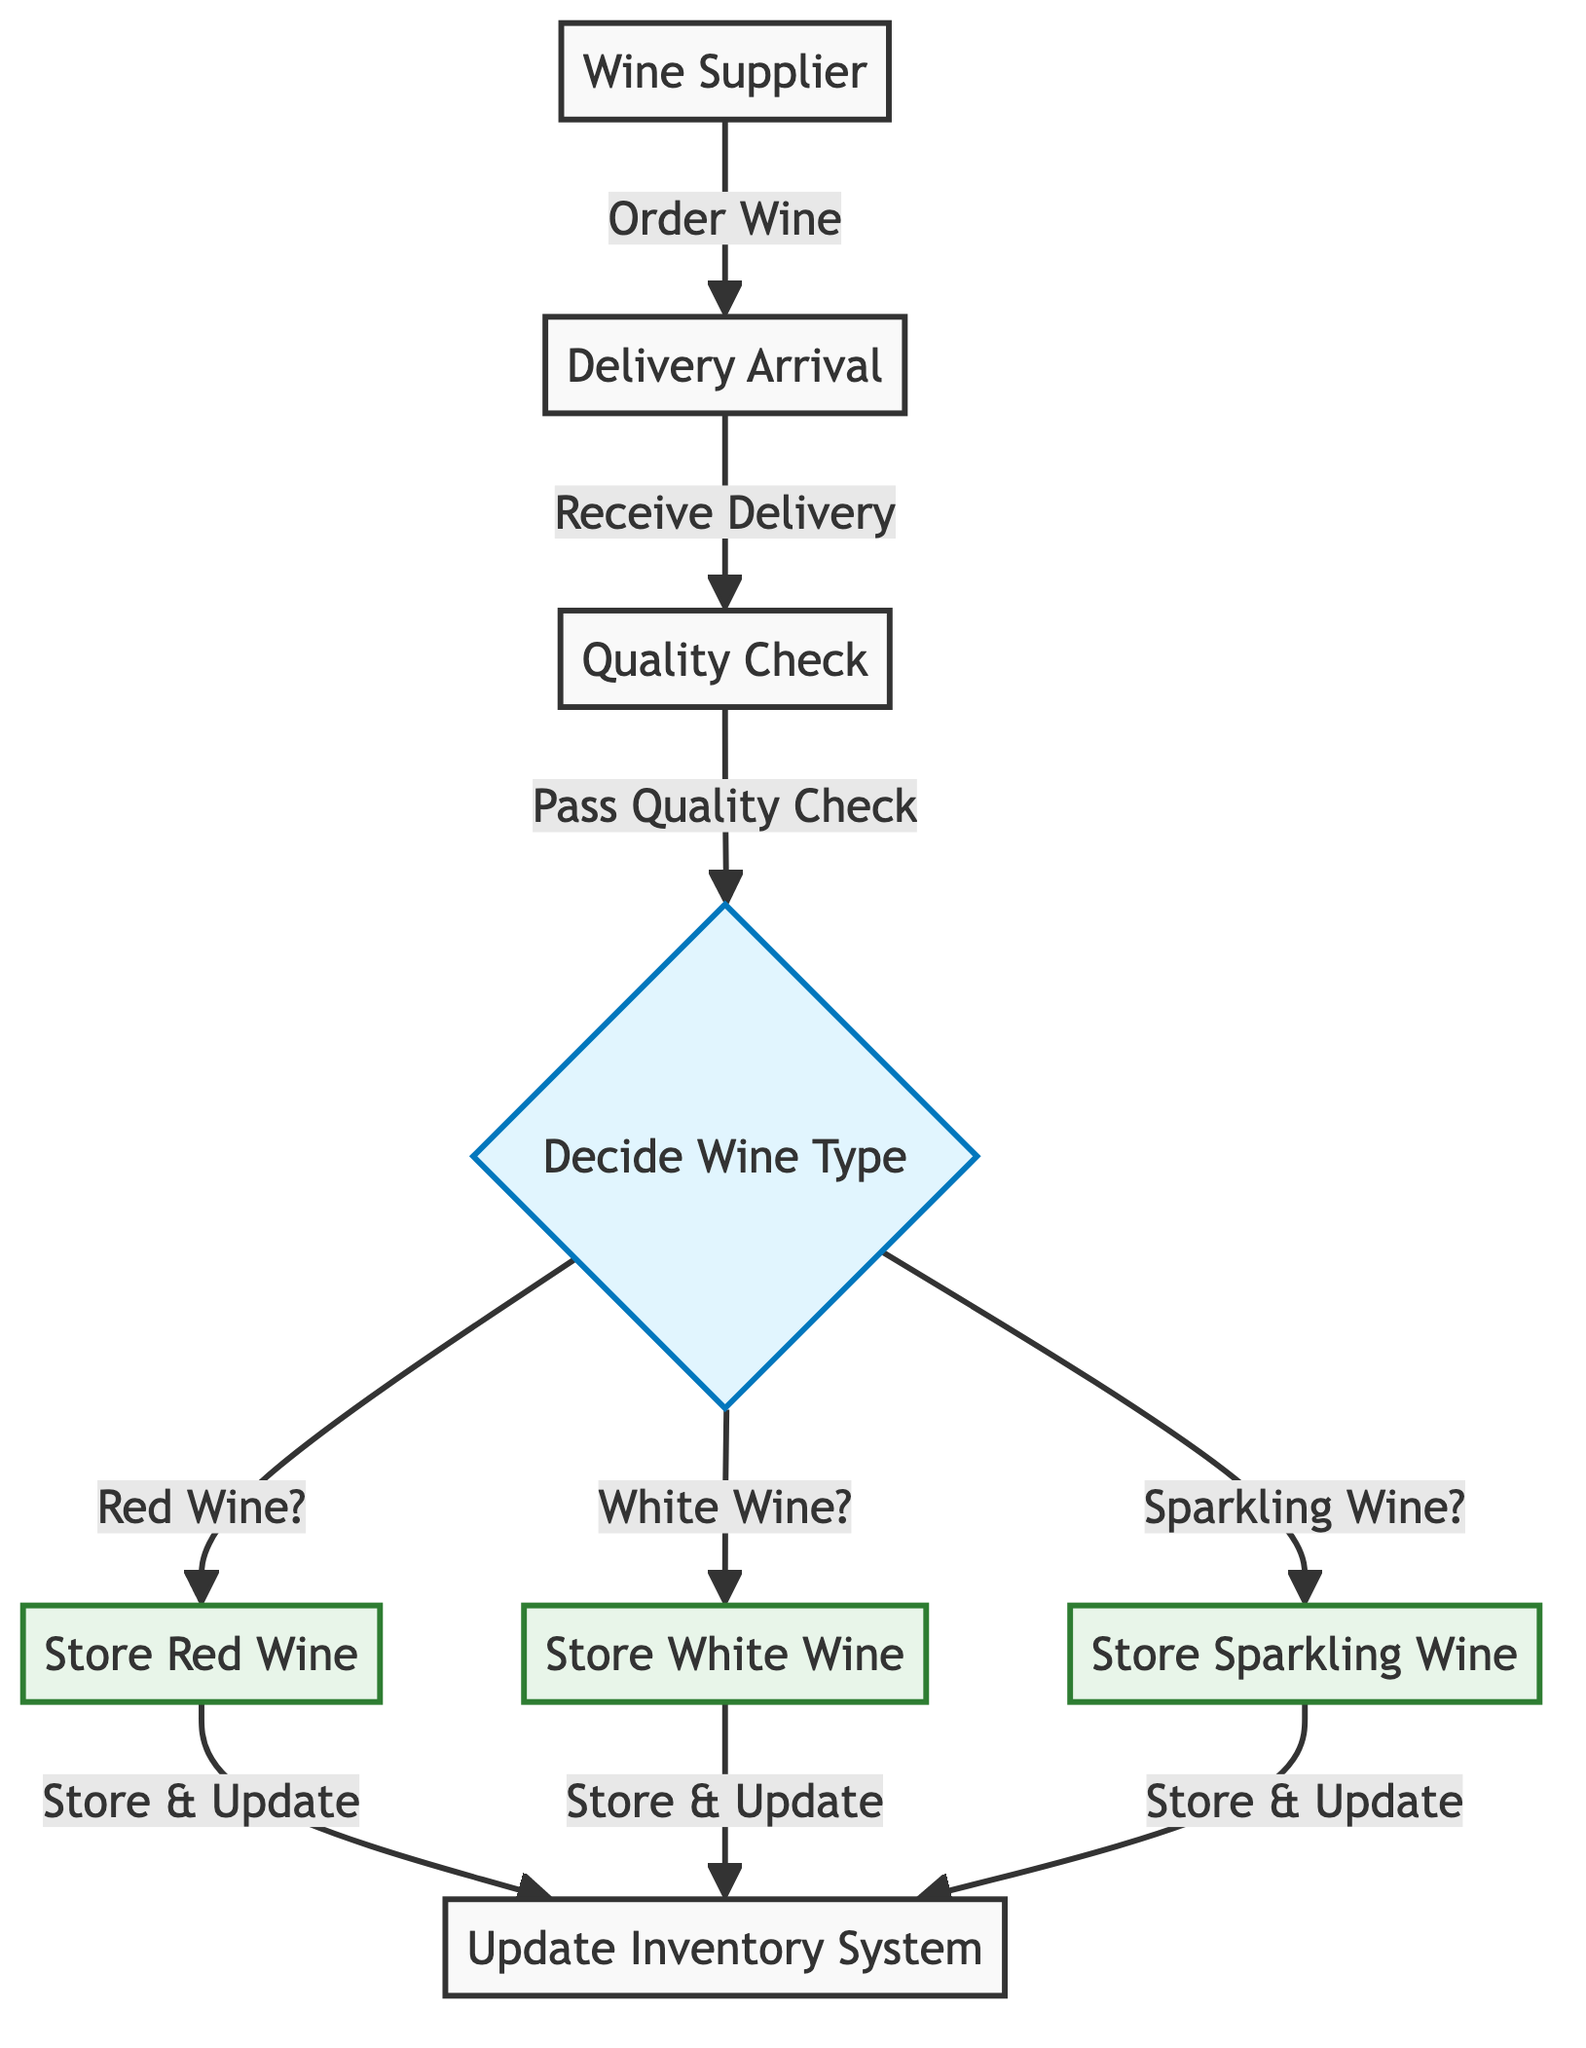What is the first step in the flowchart? The first step as per the diagram is the "Order Wine" process that involves the supplier. This indicates the starting point of the restocking process in the flowchart.
Answer: Order Wine How many types of wine are considered in the decision node? The decision node evaluates three types of wine: Red, White, and Sparkling. Each type is carefully considered during the inventory management process.
Answer: Three What happens immediately after quality check if the wine passes? After passing the quality check, the process leads to the decision on the wine type, indicating that the next action is to determine where to store the wine.
Answer: Decide Wine Type Which node follows the "Store Red Wine" node? The node that follows "Store Red Wine" is "Update Inventory System." This indicates that after storing the red wine, the inventory system must be updated promptly.
Answer: Update Inventory System What is the relationship between the "Delivery Arrival" and the "Quality Check" nodes? The "Delivery Arrival" node leads directly to the "Quality Check" node, indicating that upon the arrival of the delivery, a quality check is the subsequent step in the process.
Answer: Direct What decision is made regarding the type of wine after the quality check? The decision to determine the wine type occurs immediately after the quality check, which categorizes the wine into Red, White, or Sparkling for storage purposes.
Answer: Decide Wine Type If the wine type is sparkling, which storage node will it lead to? If the wine type is determined to be sparkling, it will direct to the "Store Sparkling Wine" node, which is specifically designated for this type of wine after quality assessment.
Answer: Store Sparkling Wine How many storage nodes are shown in the flowchart? There are three storage nodes indicated in the flowchart: "Store Red Wine," "Store White Wine," and "Store Sparkling Wine." Each represents a distinct storage location for the respective wine types.
Answer: Three What class is assigned to the decision node regarding wine type? The decision node, where the wine type is decided, is assigned the class "decision," as denoted in the diagram to differentiate it from storage nodes and standard nodes.
Answer: decision 